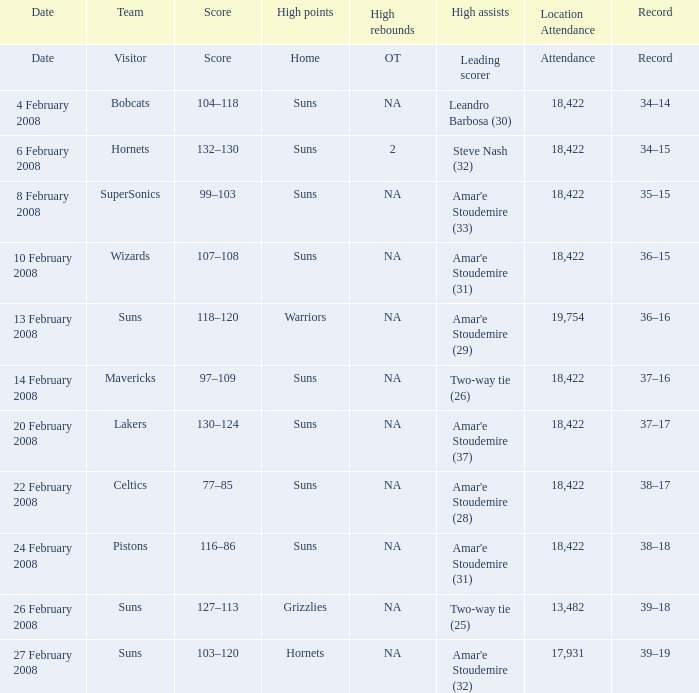What is the number of high assists for the lakers? Amar'e Stoudemire (37). Parse the table in full. {'header': ['Date', 'Team', 'Score', 'High points', 'High rebounds', 'High assists', 'Location Attendance', 'Record'], 'rows': [['Date', 'Visitor', 'Score', 'Home', 'OT', 'Leading scorer', 'Attendance', 'Record'], ['4 February 2008', 'Bobcats', '104–118', 'Suns', 'NA', 'Leandro Barbosa (30)', '18,422', '34–14'], ['6 February 2008', 'Hornets', '132–130', 'Suns', '2', 'Steve Nash (32)', '18,422', '34–15'], ['8 February 2008', 'SuperSonics', '99–103', 'Suns', 'NA', "Amar'e Stoudemire (33)", '18,422', '35–15'], ['10 February 2008', 'Wizards', '107–108', 'Suns', 'NA', "Amar'e Stoudemire (31)", '18,422', '36–15'], ['13 February 2008', 'Suns', '118–120', 'Warriors', 'NA', "Amar'e Stoudemire (29)", '19,754', '36–16'], ['14 February 2008', 'Mavericks', '97–109', 'Suns', 'NA', 'Two-way tie (26)', '18,422', '37–16'], ['20 February 2008', 'Lakers', '130–124', 'Suns', 'NA', "Amar'e Stoudemire (37)", '18,422', '37–17'], ['22 February 2008', 'Celtics', '77–85', 'Suns', 'NA', "Amar'e Stoudemire (28)", '18,422', '38–17'], ['24 February 2008', 'Pistons', '116–86', 'Suns', 'NA', "Amar'e Stoudemire (31)", '18,422', '38–18'], ['26 February 2008', 'Suns', '127–113', 'Grizzlies', 'NA', 'Two-way tie (25)', '13,482', '39–18'], ['27 February 2008', 'Suns', '103–120', 'Hornets', 'NA', "Amar'e Stoudemire (32)", '17,931', '39–19']]} 